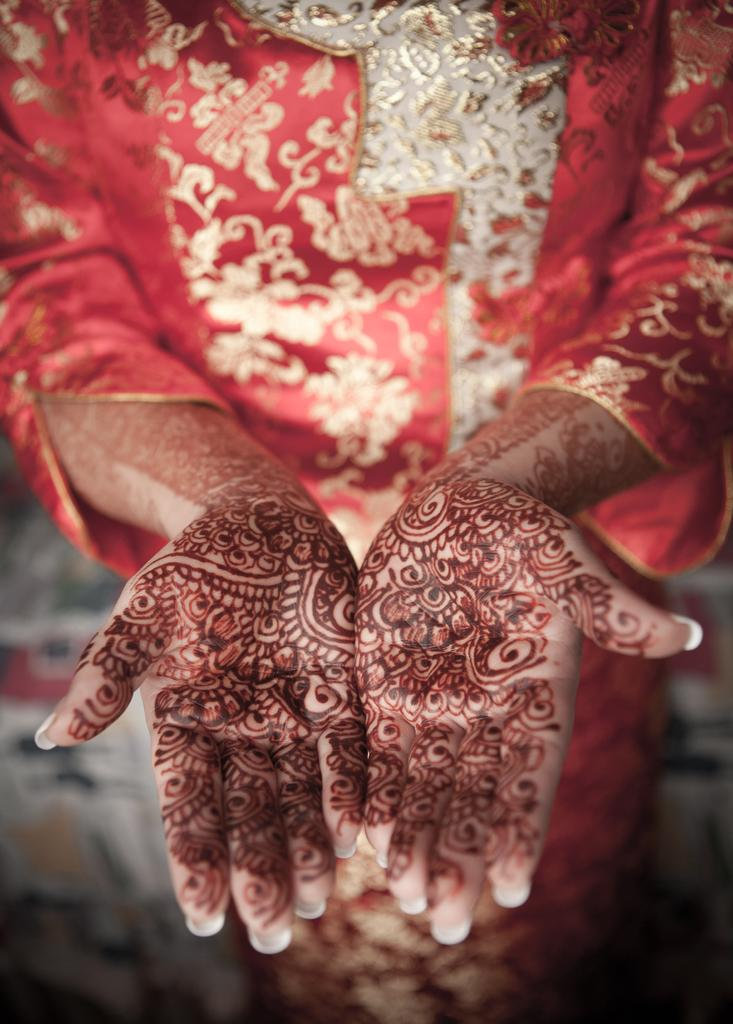What is the main subject of the image? There is a person in the image. What is the person wearing? The person is wearing a red and gold color dress. What type of van is parked next to the person in the image? There is no van present in the image; it only features a person wearing a red and gold color dress. 